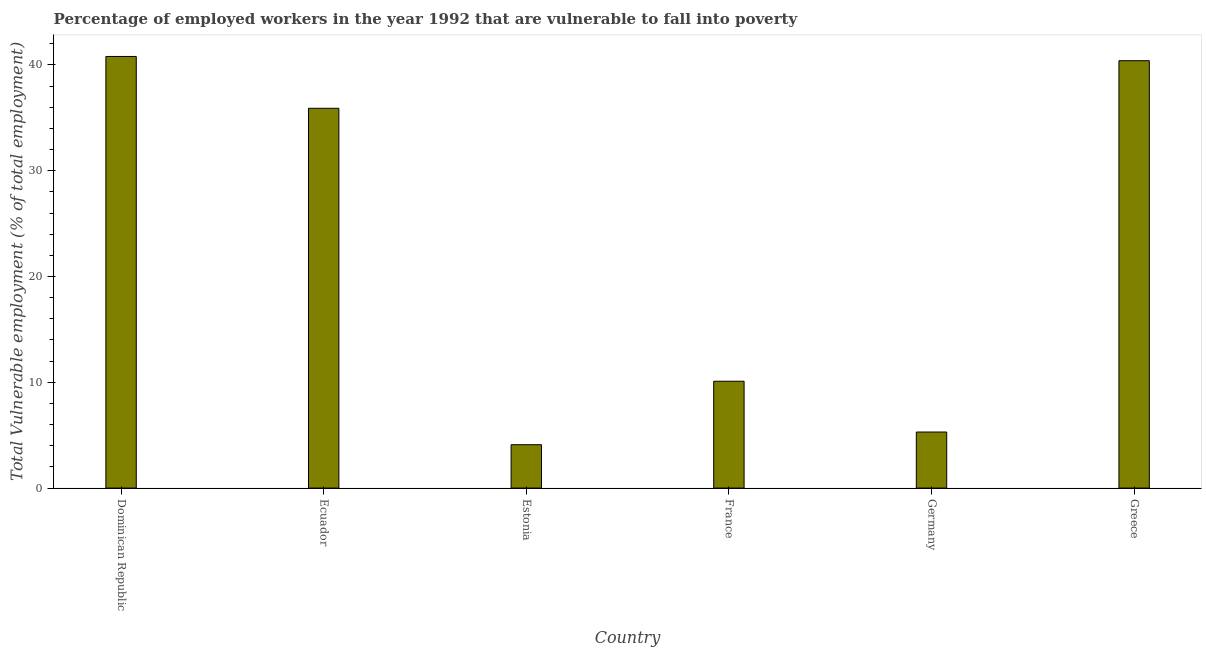What is the title of the graph?
Your answer should be compact. Percentage of employed workers in the year 1992 that are vulnerable to fall into poverty. What is the label or title of the X-axis?
Give a very brief answer. Country. What is the label or title of the Y-axis?
Offer a very short reply. Total Vulnerable employment (% of total employment). What is the total vulnerable employment in Estonia?
Your answer should be compact. 4.1. Across all countries, what is the maximum total vulnerable employment?
Keep it short and to the point. 40.8. Across all countries, what is the minimum total vulnerable employment?
Keep it short and to the point. 4.1. In which country was the total vulnerable employment maximum?
Offer a terse response. Dominican Republic. In which country was the total vulnerable employment minimum?
Ensure brevity in your answer.  Estonia. What is the sum of the total vulnerable employment?
Ensure brevity in your answer.  136.6. What is the difference between the total vulnerable employment in Dominican Republic and Ecuador?
Offer a terse response. 4.9. What is the average total vulnerable employment per country?
Your response must be concise. 22.77. What is the median total vulnerable employment?
Make the answer very short. 23. In how many countries, is the total vulnerable employment greater than 34 %?
Your answer should be compact. 3. What is the ratio of the total vulnerable employment in Dominican Republic to that in Estonia?
Your answer should be compact. 9.95. Is the difference between the total vulnerable employment in Ecuador and Estonia greater than the difference between any two countries?
Provide a short and direct response. No. What is the difference between the highest and the second highest total vulnerable employment?
Ensure brevity in your answer.  0.4. Is the sum of the total vulnerable employment in France and Greece greater than the maximum total vulnerable employment across all countries?
Ensure brevity in your answer.  Yes. What is the difference between the highest and the lowest total vulnerable employment?
Provide a succinct answer. 36.7. In how many countries, is the total vulnerable employment greater than the average total vulnerable employment taken over all countries?
Offer a terse response. 3. Are all the bars in the graph horizontal?
Make the answer very short. No. How many countries are there in the graph?
Provide a short and direct response. 6. What is the Total Vulnerable employment (% of total employment) in Dominican Republic?
Your answer should be compact. 40.8. What is the Total Vulnerable employment (% of total employment) of Ecuador?
Keep it short and to the point. 35.9. What is the Total Vulnerable employment (% of total employment) of Estonia?
Your answer should be very brief. 4.1. What is the Total Vulnerable employment (% of total employment) in France?
Provide a short and direct response. 10.1. What is the Total Vulnerable employment (% of total employment) of Germany?
Provide a short and direct response. 5.3. What is the Total Vulnerable employment (% of total employment) in Greece?
Keep it short and to the point. 40.4. What is the difference between the Total Vulnerable employment (% of total employment) in Dominican Republic and Estonia?
Make the answer very short. 36.7. What is the difference between the Total Vulnerable employment (% of total employment) in Dominican Republic and France?
Keep it short and to the point. 30.7. What is the difference between the Total Vulnerable employment (% of total employment) in Dominican Republic and Germany?
Provide a short and direct response. 35.5. What is the difference between the Total Vulnerable employment (% of total employment) in Ecuador and Estonia?
Offer a very short reply. 31.8. What is the difference between the Total Vulnerable employment (% of total employment) in Ecuador and France?
Offer a terse response. 25.8. What is the difference between the Total Vulnerable employment (% of total employment) in Ecuador and Germany?
Your response must be concise. 30.6. What is the difference between the Total Vulnerable employment (% of total employment) in Estonia and France?
Make the answer very short. -6. What is the difference between the Total Vulnerable employment (% of total employment) in Estonia and Germany?
Offer a very short reply. -1.2. What is the difference between the Total Vulnerable employment (% of total employment) in Estonia and Greece?
Ensure brevity in your answer.  -36.3. What is the difference between the Total Vulnerable employment (% of total employment) in France and Greece?
Give a very brief answer. -30.3. What is the difference between the Total Vulnerable employment (% of total employment) in Germany and Greece?
Give a very brief answer. -35.1. What is the ratio of the Total Vulnerable employment (% of total employment) in Dominican Republic to that in Ecuador?
Keep it short and to the point. 1.14. What is the ratio of the Total Vulnerable employment (% of total employment) in Dominican Republic to that in Estonia?
Give a very brief answer. 9.95. What is the ratio of the Total Vulnerable employment (% of total employment) in Dominican Republic to that in France?
Your answer should be very brief. 4.04. What is the ratio of the Total Vulnerable employment (% of total employment) in Dominican Republic to that in Germany?
Offer a very short reply. 7.7. What is the ratio of the Total Vulnerable employment (% of total employment) in Ecuador to that in Estonia?
Provide a succinct answer. 8.76. What is the ratio of the Total Vulnerable employment (% of total employment) in Ecuador to that in France?
Keep it short and to the point. 3.55. What is the ratio of the Total Vulnerable employment (% of total employment) in Ecuador to that in Germany?
Give a very brief answer. 6.77. What is the ratio of the Total Vulnerable employment (% of total employment) in Ecuador to that in Greece?
Keep it short and to the point. 0.89. What is the ratio of the Total Vulnerable employment (% of total employment) in Estonia to that in France?
Make the answer very short. 0.41. What is the ratio of the Total Vulnerable employment (% of total employment) in Estonia to that in Germany?
Provide a short and direct response. 0.77. What is the ratio of the Total Vulnerable employment (% of total employment) in Estonia to that in Greece?
Give a very brief answer. 0.1. What is the ratio of the Total Vulnerable employment (% of total employment) in France to that in Germany?
Your answer should be compact. 1.91. What is the ratio of the Total Vulnerable employment (% of total employment) in France to that in Greece?
Your answer should be very brief. 0.25. What is the ratio of the Total Vulnerable employment (% of total employment) in Germany to that in Greece?
Offer a very short reply. 0.13. 